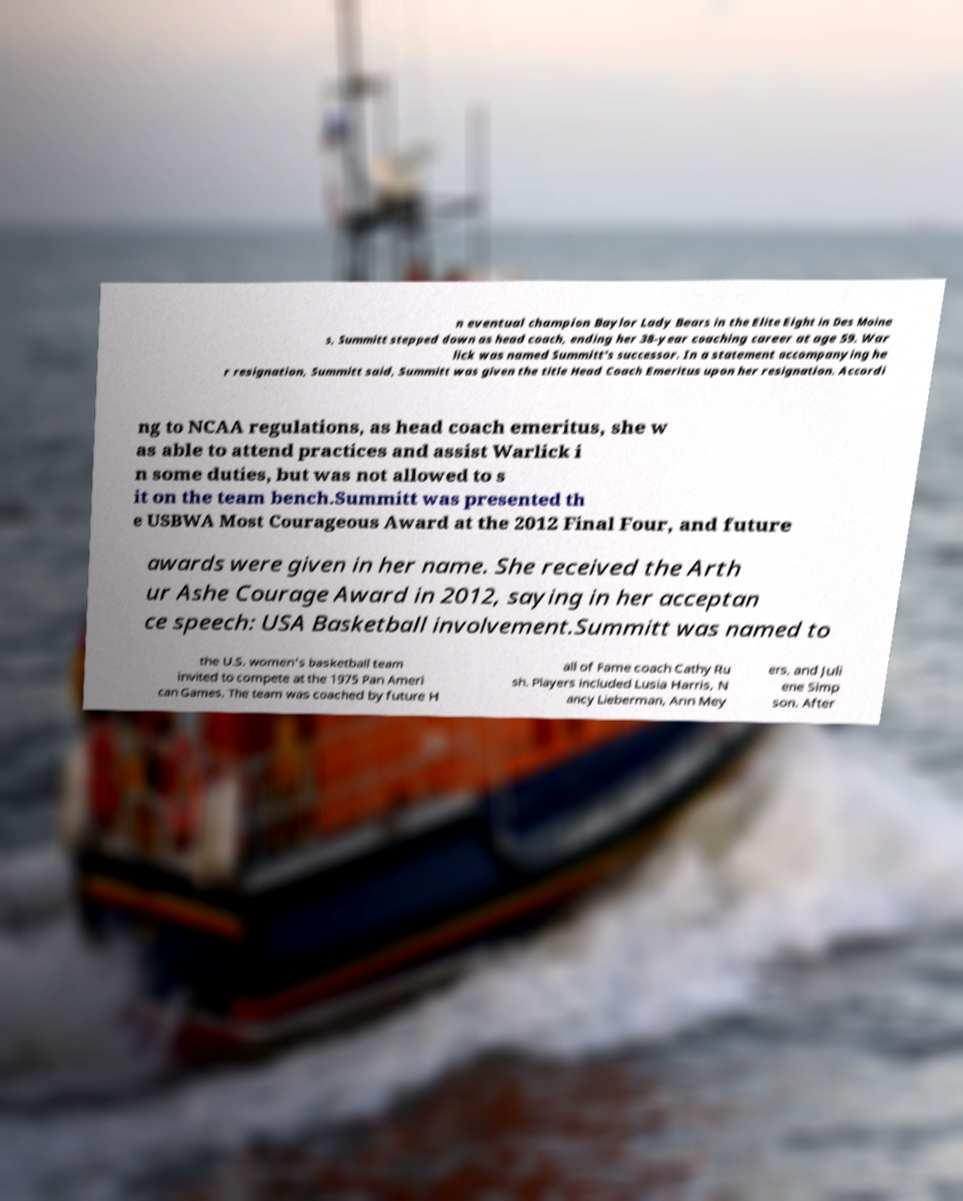There's text embedded in this image that I need extracted. Can you transcribe it verbatim? n eventual champion Baylor Lady Bears in the Elite Eight in Des Moine s, Summitt stepped down as head coach, ending her 38-year coaching career at age 59. War lick was named Summitt's successor. In a statement accompanying he r resignation, Summitt said, Summitt was given the title Head Coach Emeritus upon her resignation. Accordi ng to NCAA regulations, as head coach emeritus, she w as able to attend practices and assist Warlick i n some duties, but was not allowed to s it on the team bench.Summitt was presented th e USBWA Most Courageous Award at the 2012 Final Four, and future awards were given in her name. She received the Arth ur Ashe Courage Award in 2012, saying in her acceptan ce speech: USA Basketball involvement.Summitt was named to the U.S. women's basketball team invited to compete at the 1975 Pan Ameri can Games. The team was coached by future H all of Fame coach Cathy Ru sh. Players included Lusia Harris, N ancy Lieberman, Ann Mey ers, and Juli ene Simp son. After 